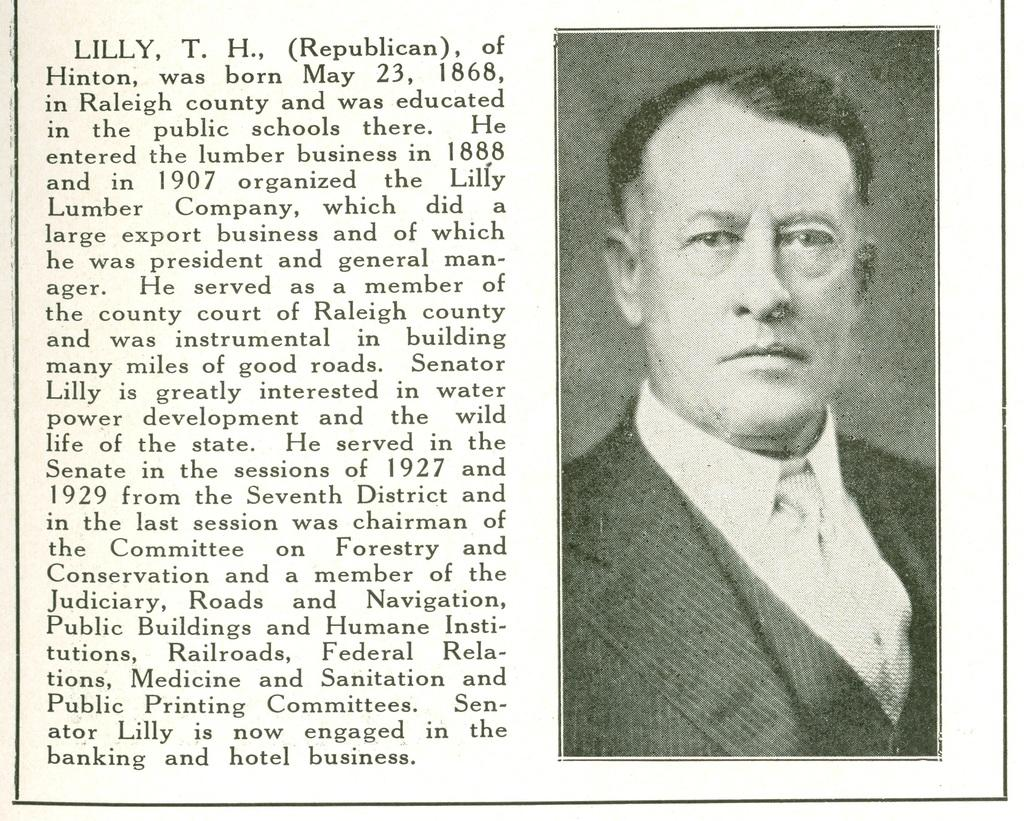What is present on the paper in the image? There are words and numbers on the paper in the image. Is there any visual representation on the paper? Yes, there is an image of a person on the paper. How many eggs are being fanned by the tin in the image? There are no eggs, tin, or fan present in the image. 